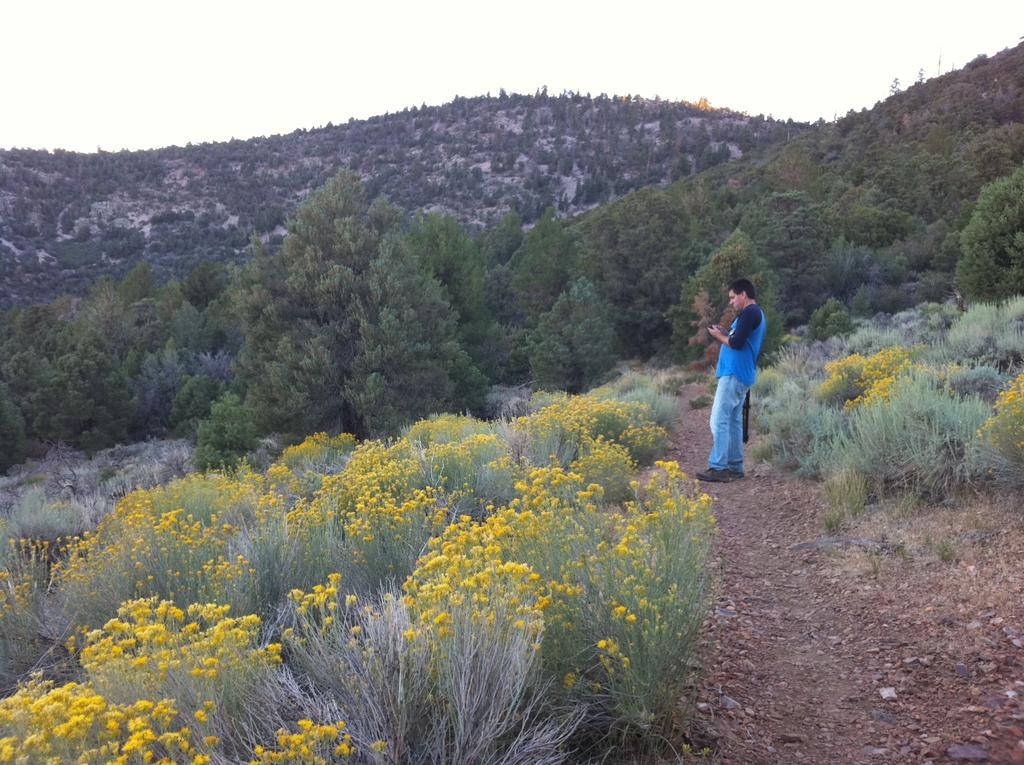What is the person in the image doing? The person is standing on the land. What can be found on the land in the image? There are plants and trees on the land. Are there any plants with flowers in the image? Yes, some plants have flowers in the image. What can be seen in the background of the image? There are hills in the background. What is visible at the top of the image? The sky is visible at the top of the image. What type of engine is visible in the image? There is no engine present in the image. 